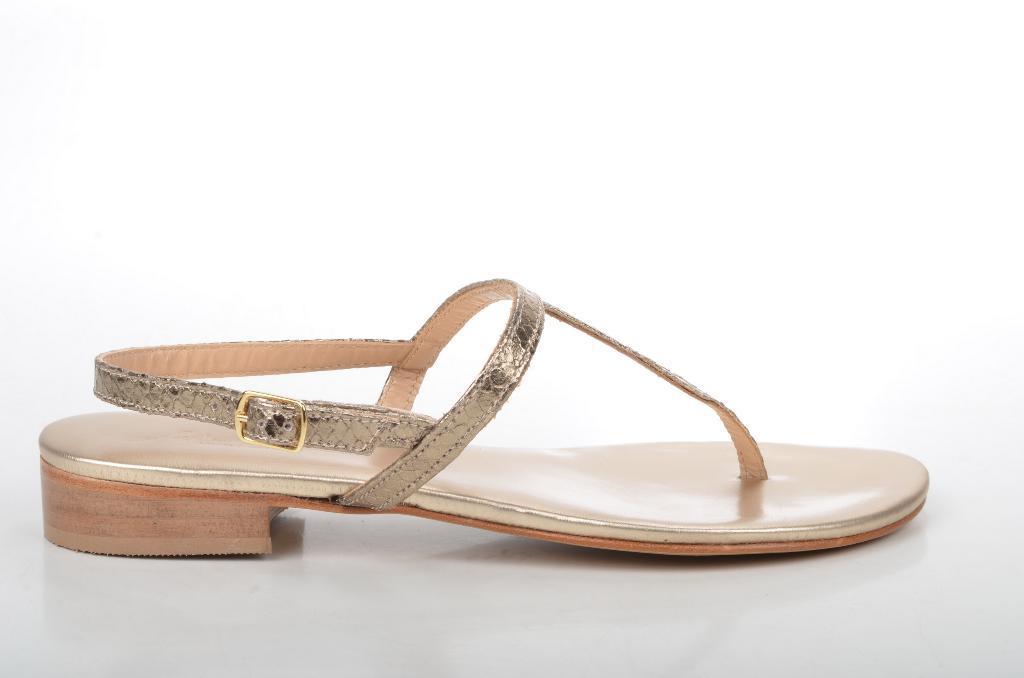Can you describe this image briefly? In this picture we can see a sandal placed on a platform. 